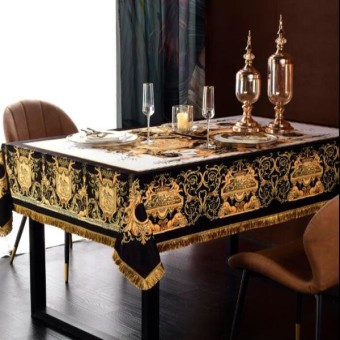How many dining tables are there in the image? There is one elaborately decorated dining table in the image, featuring a luxurious tablecloth with ornate patterns, set for a meal with elegant tableware and tall decorative candlesticks that suggest a sophisticated dining setting. 